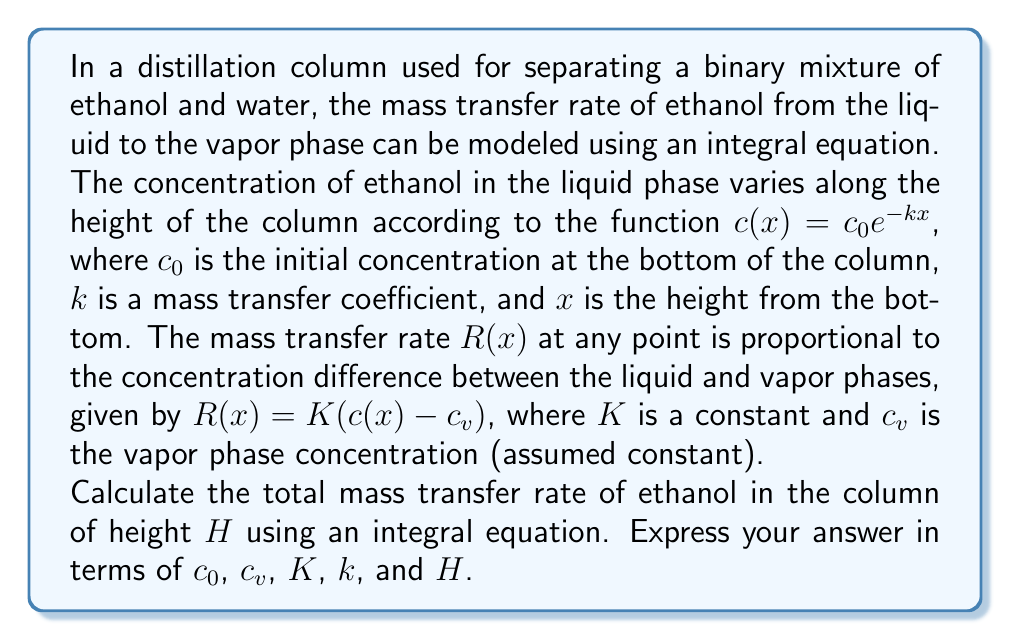Teach me how to tackle this problem. To solve this problem, we'll follow these steps:

1) The total mass transfer rate is the integral of the mass transfer rate function $R(x)$ over the height of the column:

   $$M_{total} = \int_0^H R(x) dx$$

2) Substitute the expression for $R(x)$:

   $$M_{total} = \int_0^H K(c(x) - c_v) dx$$

3) Now, substitute the expression for $c(x)$:

   $$M_{total} = \int_0^H K(c_0 e^{-kx} - c_v) dx$$

4) Distribute $K$:

   $$M_{total} = K \int_0^H (c_0 e^{-kx} - c_v) dx$$

5) Split the integral:

   $$M_{total} = K \left[\int_0^H c_0 e^{-kx} dx - \int_0^H c_v dx\right]$$

6) Solve the integrals:
   
   For the first integral: $\int e^{-kx} dx = -\frac{1}{k}e^{-kx} + C$
   
   For the second integral: $\int c_v dx = c_v x + C$

   $$M_{total} = K \left[-\frac{c_0}{k}e^{-kx}\bigg|_0^H - c_v x\bigg|_0^H\right]$$

7) Evaluate the limits:

   $$M_{total} = K \left[-\frac{c_0}{k}(e^{-kH} - 1) - c_v H\right]$$

8) Simplify:

   $$M_{total} = K \left[\frac{c_0}{k}(1 - e^{-kH}) - c_v H\right]$$

This is the final expression for the total mass transfer rate in the column.
Answer: $K \left[\frac{c_0}{k}(1 - e^{-kH}) - c_v H\right]$ 